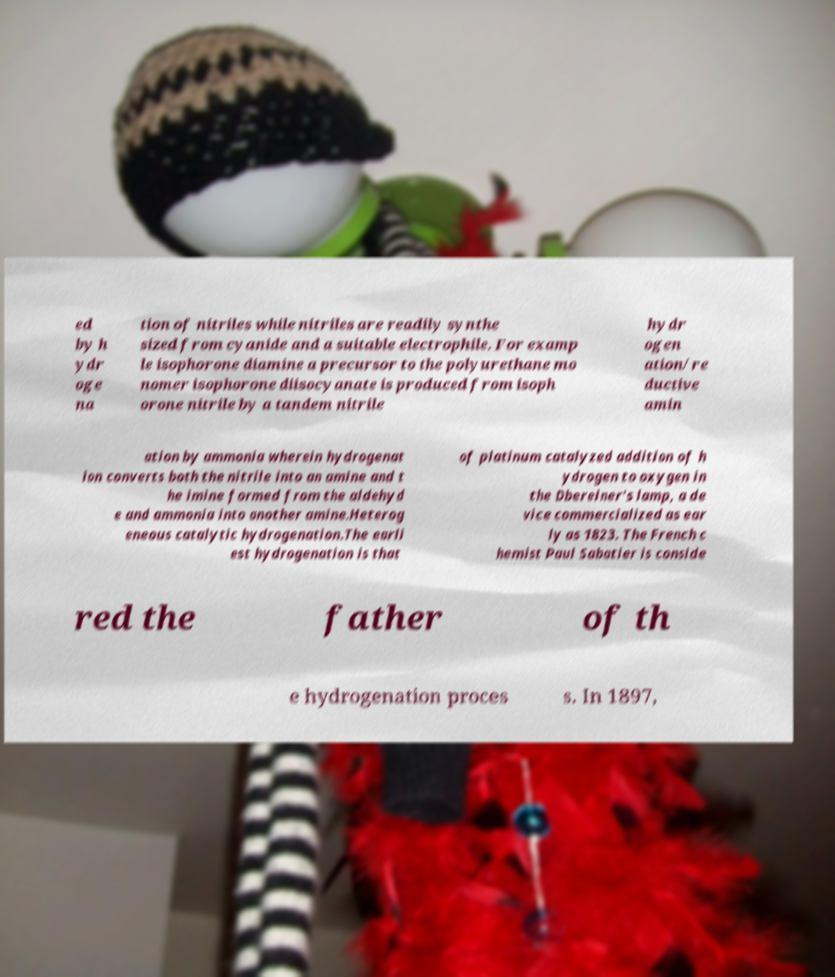Please identify and transcribe the text found in this image. ed by h ydr oge na tion of nitriles while nitriles are readily synthe sized from cyanide and a suitable electrophile. For examp le isophorone diamine a precursor to the polyurethane mo nomer isophorone diisocyanate is produced from isoph orone nitrile by a tandem nitrile hydr ogen ation/re ductive amin ation by ammonia wherein hydrogenat ion converts both the nitrile into an amine and t he imine formed from the aldehyd e and ammonia into another amine.Heterog eneous catalytic hydrogenation.The earli est hydrogenation is that of platinum catalyzed addition of h ydrogen to oxygen in the Dbereiner's lamp, a de vice commercialized as ear ly as 1823. The French c hemist Paul Sabatier is conside red the father of th e hydrogenation proces s. In 1897, 